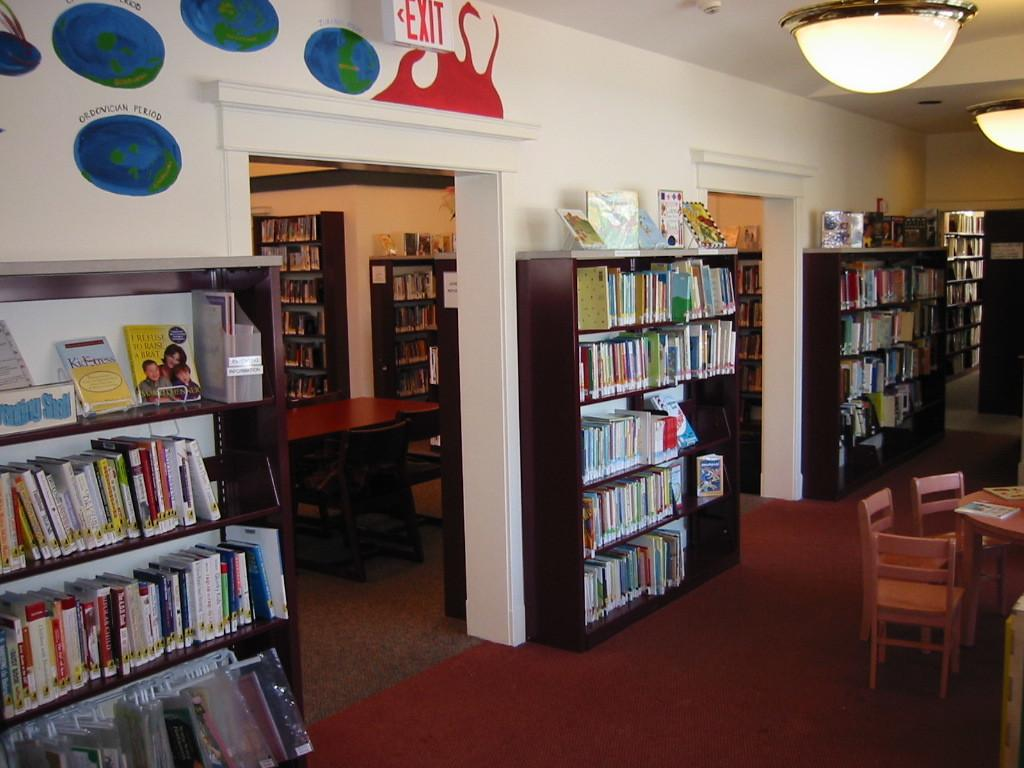What type of establishment is shown in the image? The image depicts a library. What can be found on the walls of the library? There are shelves in the library. What is stored on the shelves? Books are placed on the shelves. What is used to provide light in the library? There are lamps in the library. What type of furniture is available for sitting in the library? Chairs are present in the library. What type of furniture is available for working or reading in the library? Tables are in the library. What type of pancake is being served at the library in the image? There is no pancake present in the image; the image depicts a library with shelves, books, lamps, chairs, and tables. 